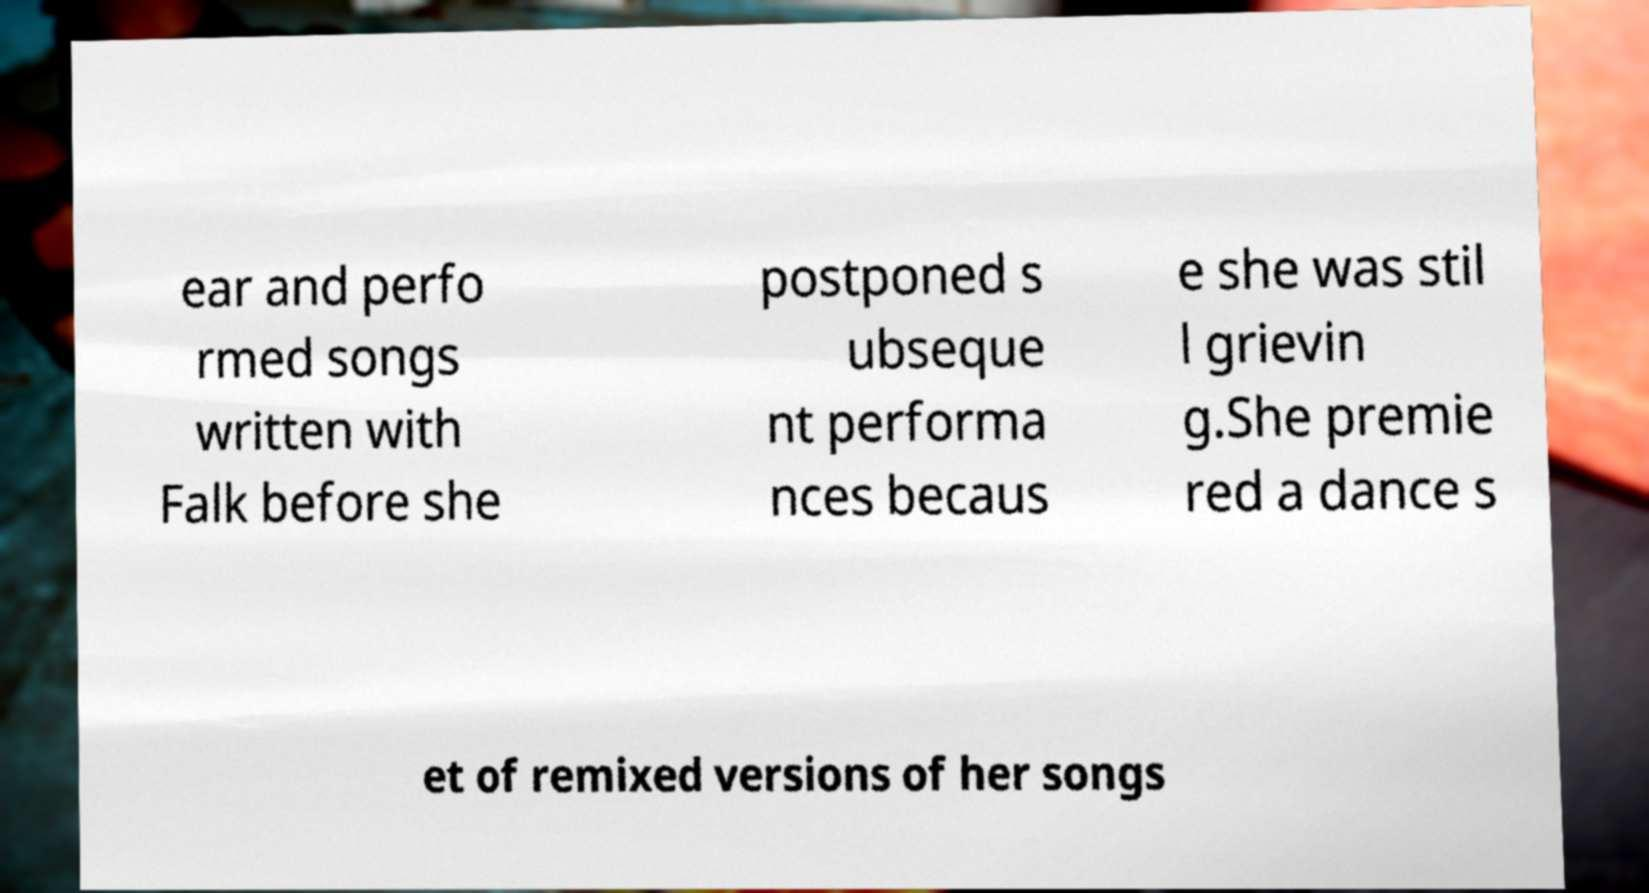Please read and relay the text visible in this image. What does it say? ear and perfo rmed songs written with Falk before she postponed s ubseque nt performa nces becaus e she was stil l grievin g.She premie red a dance s et of remixed versions of her songs 